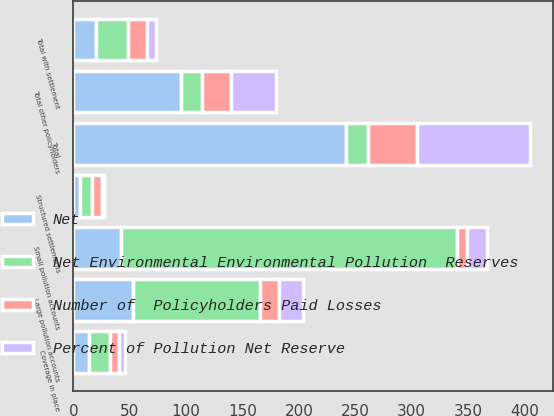Convert chart to OTSL. <chart><loc_0><loc_0><loc_500><loc_500><stacked_bar_chart><ecel><fcel>Structured settlements<fcel>Coverage in place<fcel>Total with settlement<fcel>Large pollution accounts<fcel>Small pollution accounts<fcel>Total other policyholders<fcel>Total<nl><fcel>Net Environmental Environmental Pollution  Reserves<fcel>10<fcel>18<fcel>28<fcel>112<fcel>298<fcel>19<fcel>19<nl><fcel>Number of  Policyholders Paid Losses<fcel>9<fcel>8<fcel>17<fcel>17<fcel>9<fcel>26<fcel>44<nl><fcel>Net<fcel>6<fcel>14<fcel>20<fcel>53<fcel>42<fcel>95<fcel>242<nl><fcel>Percent of Pollution Net Reserve<fcel>2.5<fcel>5.8<fcel>8.3<fcel>21.9<fcel>17.4<fcel>39.3<fcel>100<nl></chart> 